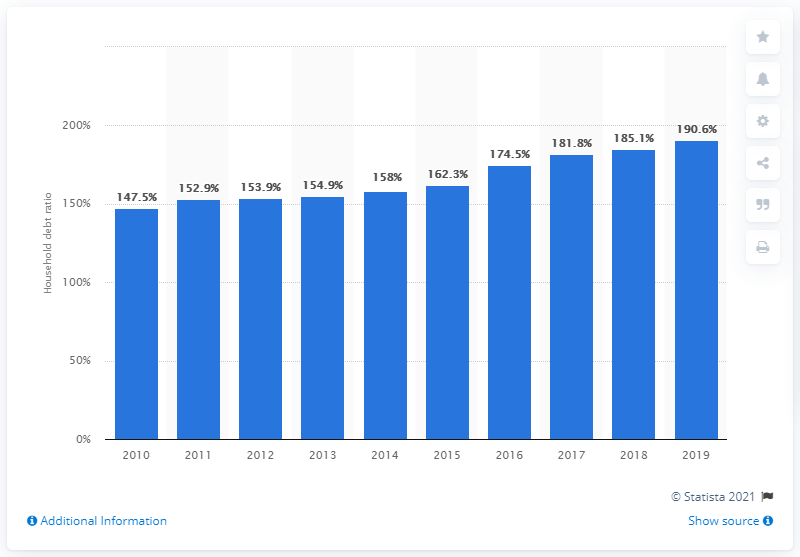Mention a couple of crucial points in this snapshot. The debt-to-income ratio among South Korean households in 2019 was 190.6%. 